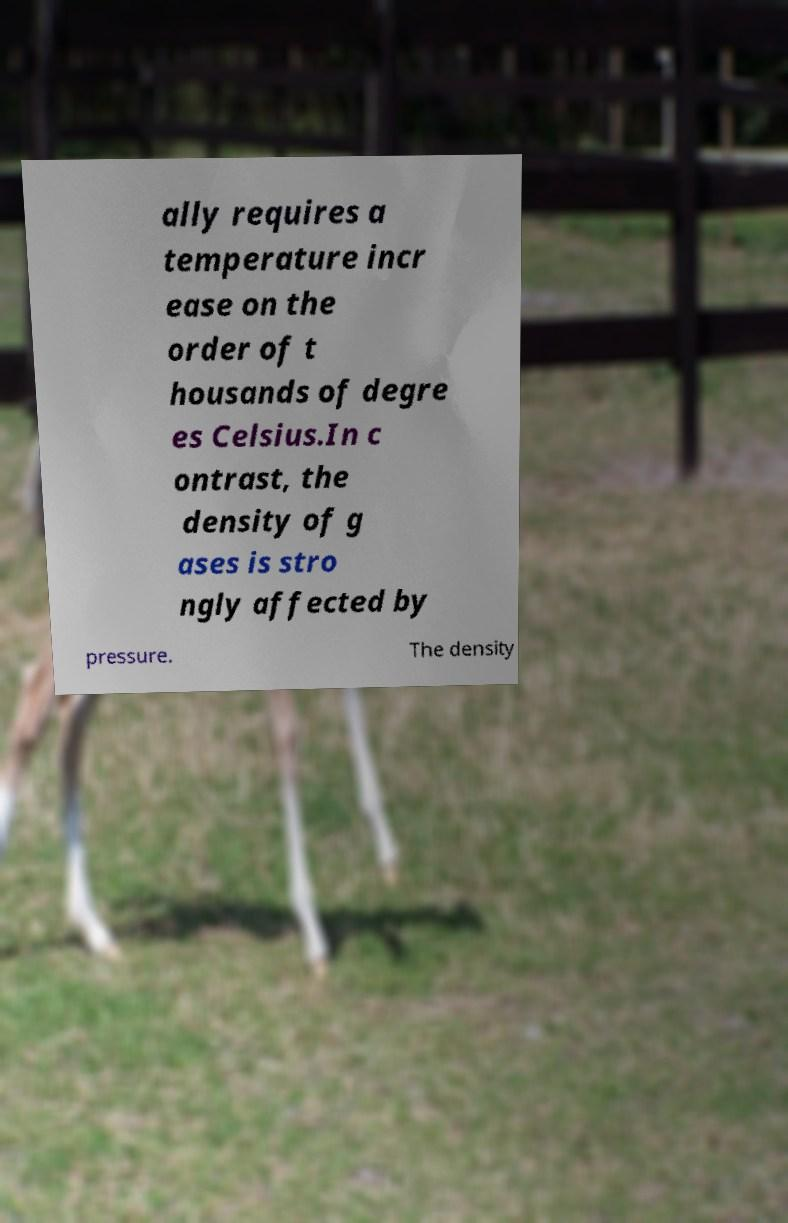There's text embedded in this image that I need extracted. Can you transcribe it verbatim? ally requires a temperature incr ease on the order of t housands of degre es Celsius.In c ontrast, the density of g ases is stro ngly affected by pressure. The density 